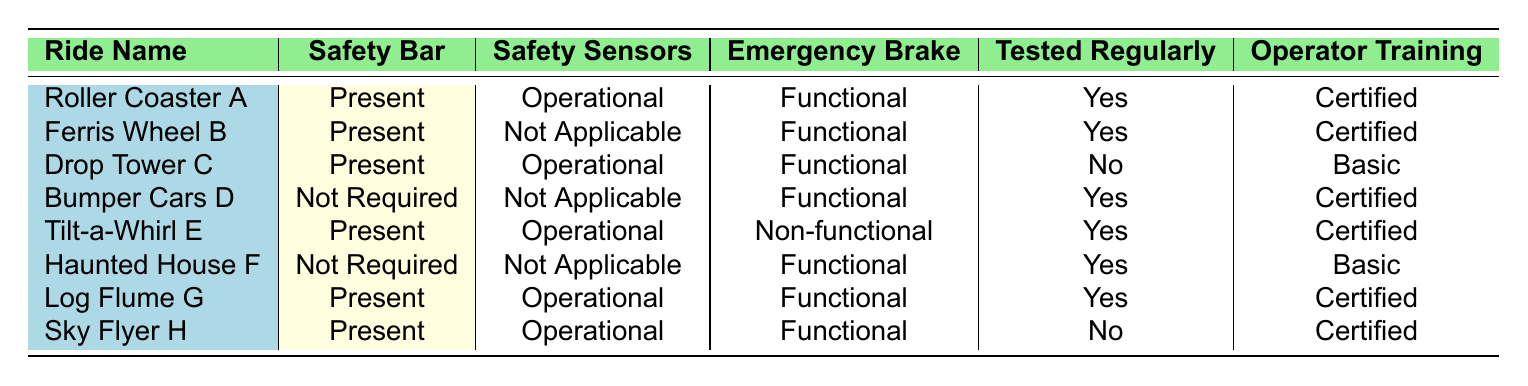What rides have the safety bar present? To find the rides with a safety bar present, we look at the "Safety Bar" column and filter for entries with the value "Present". This applies to Roller Coaster A, Ferris Wheel B, Drop Tower C, Tilt-a-Whirl E, Log Flume G, and Sky Flyer H.
Answer: Roller Coaster A, Ferris Wheel B, Drop Tower C, Tilt-a-Whirl E, Log Flume G, Sky Flyer H Which ride has a non-functional emergency brake? We need to check the "Emergency Brake" column for the value "Non-functional". The only ride that meets this criterion is Tilt-a-Whirl E.
Answer: Tilt-a-Whirl E Are all rides tested regularly? To answer this, we examine the "Tested Regularly" column. We find that Drop Tower C and Sky Flyer H report "No", indicating that not all rides are tested regularly.
Answer: No How many rides have certified operator training? We can count the rows where the value in the "Operator Training" column is "Certified". The rides with certified operator training are Roller Coaster A, Ferris Wheel B, Bumper Cars D, Log Flume G, and Sky Flyer H. That gives us a total of five rides.
Answer: 5 What is the total number of rides that have functional emergency brakes? We check the "Emergency Brake" column for the value "Functional". The rides with this feature are Roller Coaster A, Ferris Wheel B, Drop Tower C, Bumper Cars D, Haunted House F, Log Flume G, and Sky Flyer H. Counting these, we find there are six rides.
Answer: 6 Does the Ferris Wheel B have operator training that is certified? We check the "Operator Training" column for Ferris Wheel B. It states "Certified", confirming that it has certified operator training.
Answer: Yes Which ride has the least safety features based on the provided table attributes? "Least safety features" can be interpreted in multiple ways, but if we look at the ride with the highest number of features marked as "Not Required" or "Not Applicable," we find Bumper Cars D and Haunted House F, each having 3 such attributes. However, Haunted House F has only basic operator training, which could imply fewer overall features compared to Bumper Cars D.
Answer: Haunted House F What is the percentage of rides with the emergency brake functional? There are 8 rides in total, and 6 of them (all except Tilt-a-Whirl E) have functional emergency brakes. To calculate the percentage, we take (6/8) * 100 = 75%.
Answer: 75% Which safety feature is applicable to the most rides? By reviewing the "Safety Bar", we see that "Present" applies to 6 rides (all except Bumper Cars D and Haunted House F), while "Not Required" applies only to 2 rides. Therefore, the "Safety Bar" is the most prevalent feature.
Answer: Safety Bar 